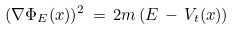Convert formula to latex. <formula><loc_0><loc_0><loc_500><loc_500>( \nabla \Phi _ { E } ( x ) ) ^ { 2 } \, = \, 2 m \, ( E \, - \, V _ { t } ( x ) )</formula> 